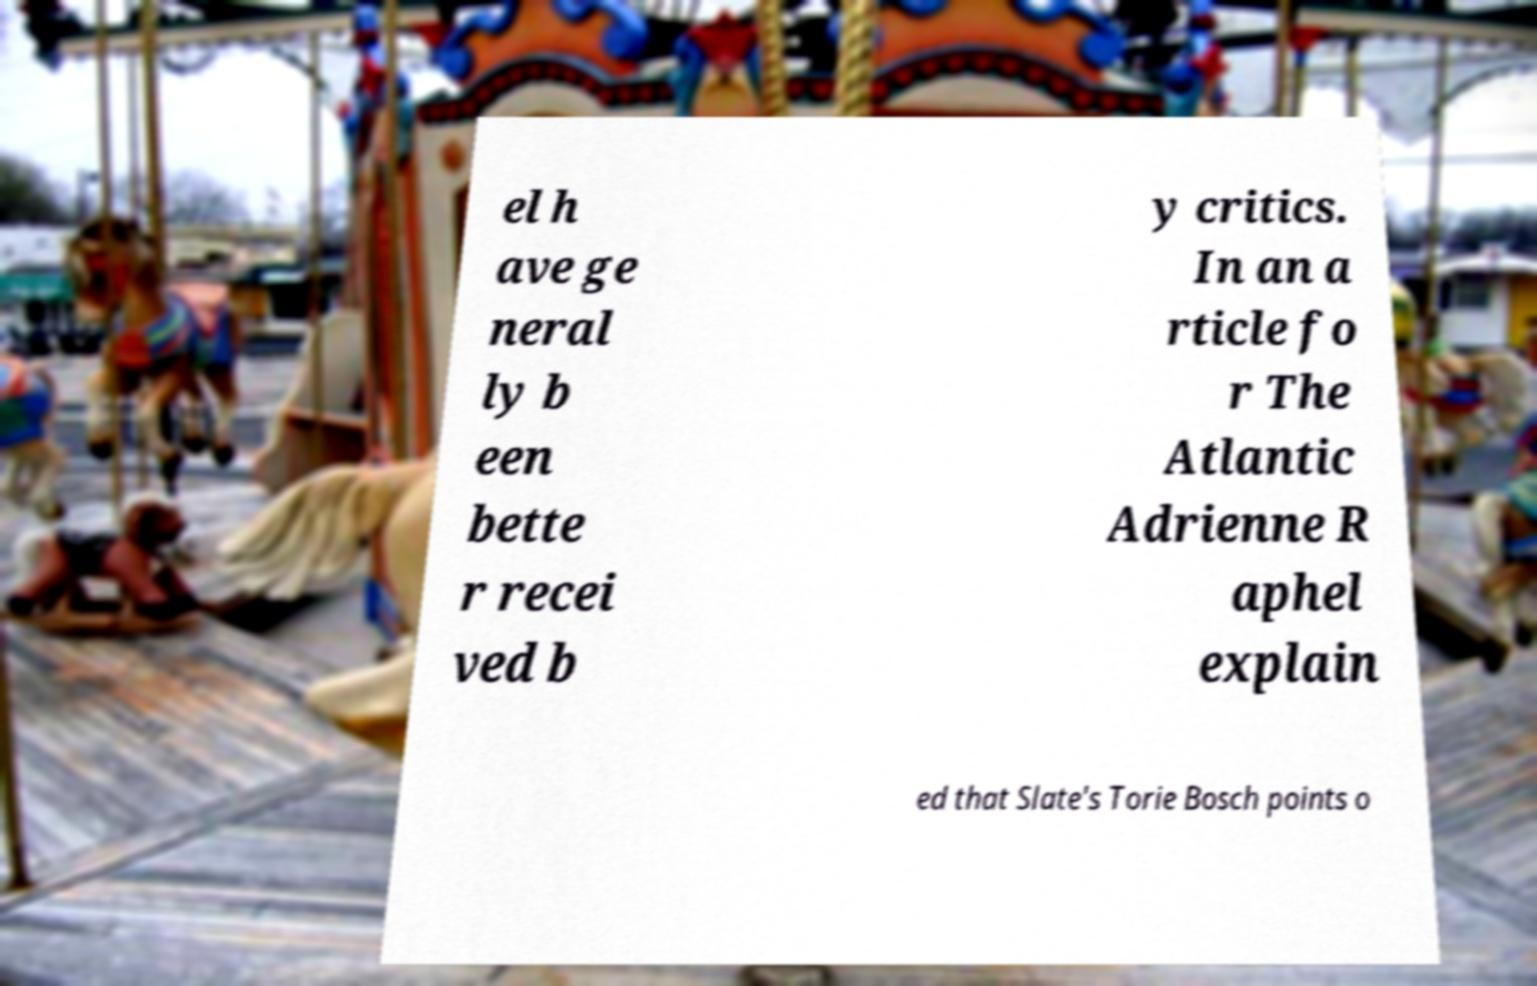Could you assist in decoding the text presented in this image and type it out clearly? el h ave ge neral ly b een bette r recei ved b y critics. In an a rticle fo r The Atlantic Adrienne R aphel explain ed that Slate's Torie Bosch points o 